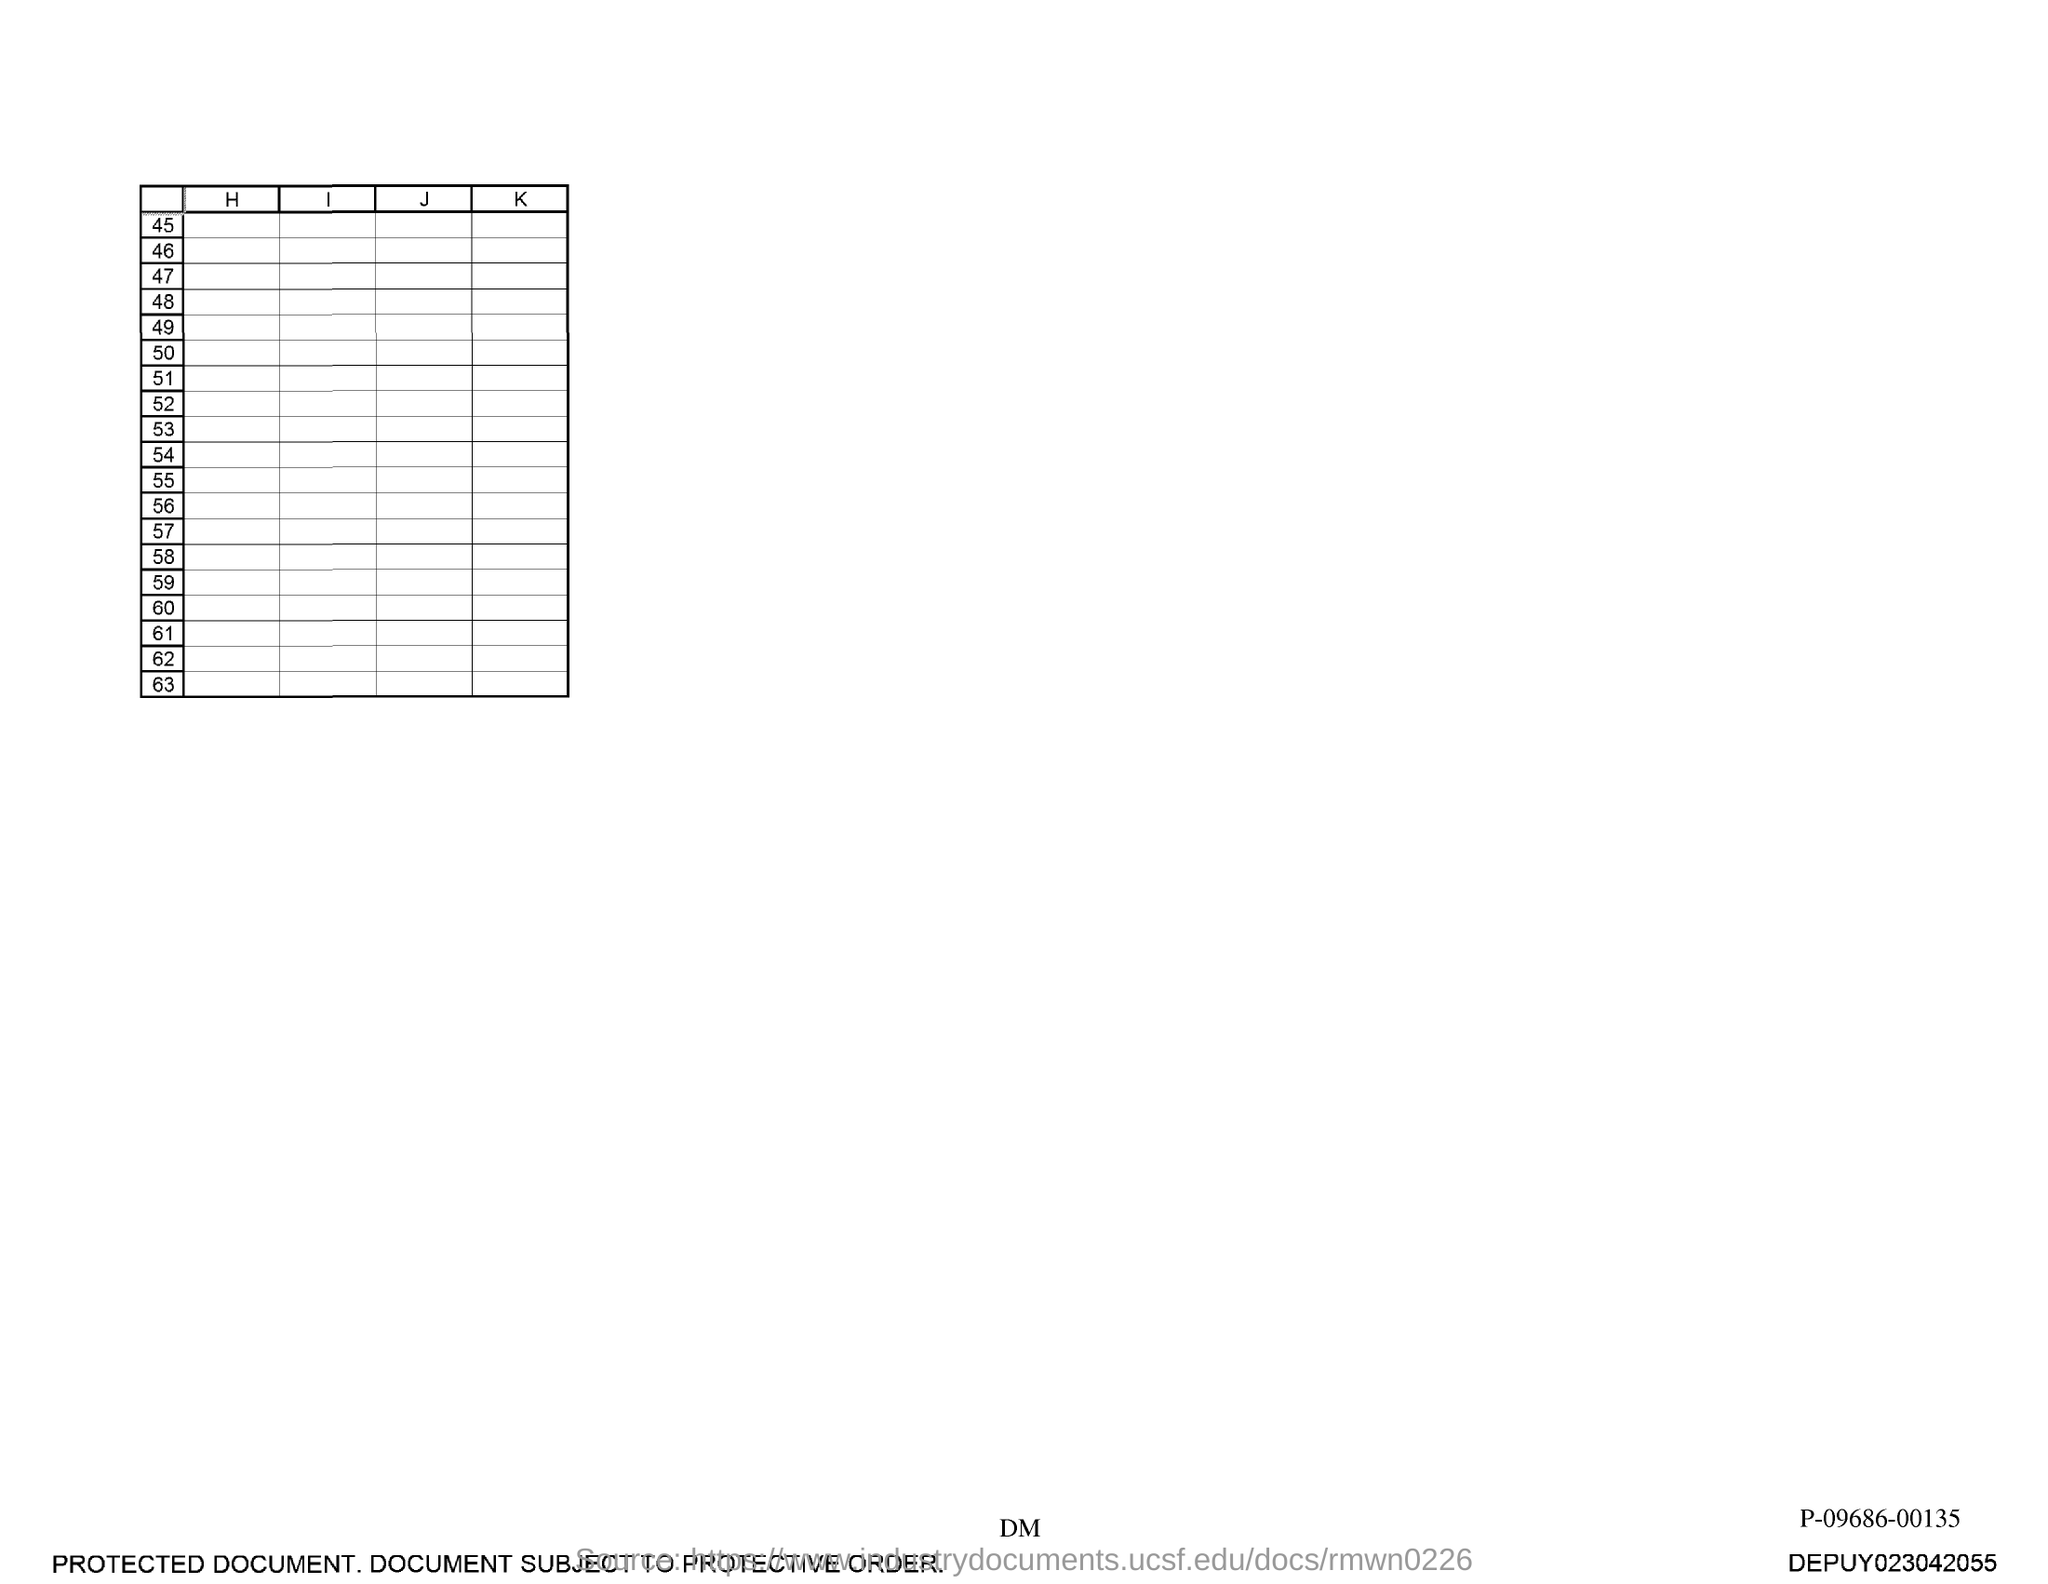Specify some key components in this picture. The last number in the first column is 63. 